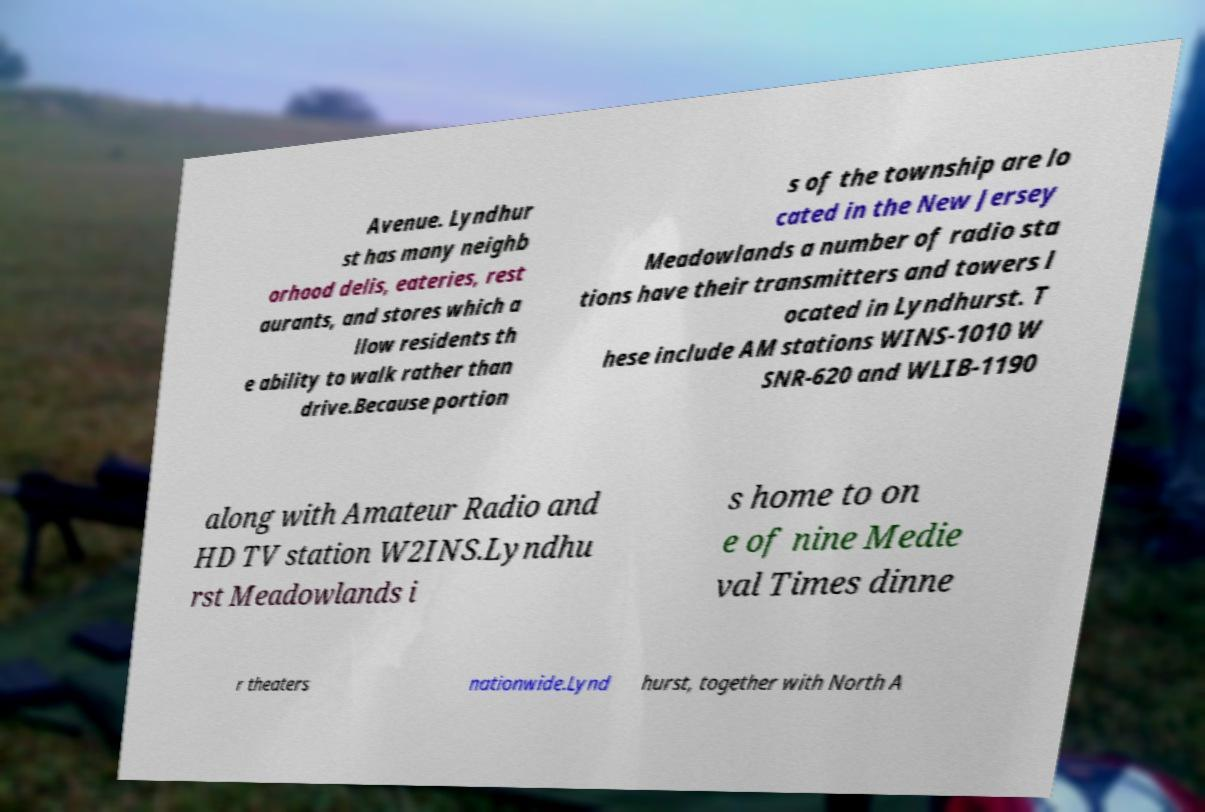What messages or text are displayed in this image? I need them in a readable, typed format. Avenue. Lyndhur st has many neighb orhood delis, eateries, rest aurants, and stores which a llow residents th e ability to walk rather than drive.Because portion s of the township are lo cated in the New Jersey Meadowlands a number of radio sta tions have their transmitters and towers l ocated in Lyndhurst. T hese include AM stations WINS-1010 W SNR-620 and WLIB-1190 along with Amateur Radio and HD TV station W2INS.Lyndhu rst Meadowlands i s home to on e of nine Medie val Times dinne r theaters nationwide.Lynd hurst, together with North A 